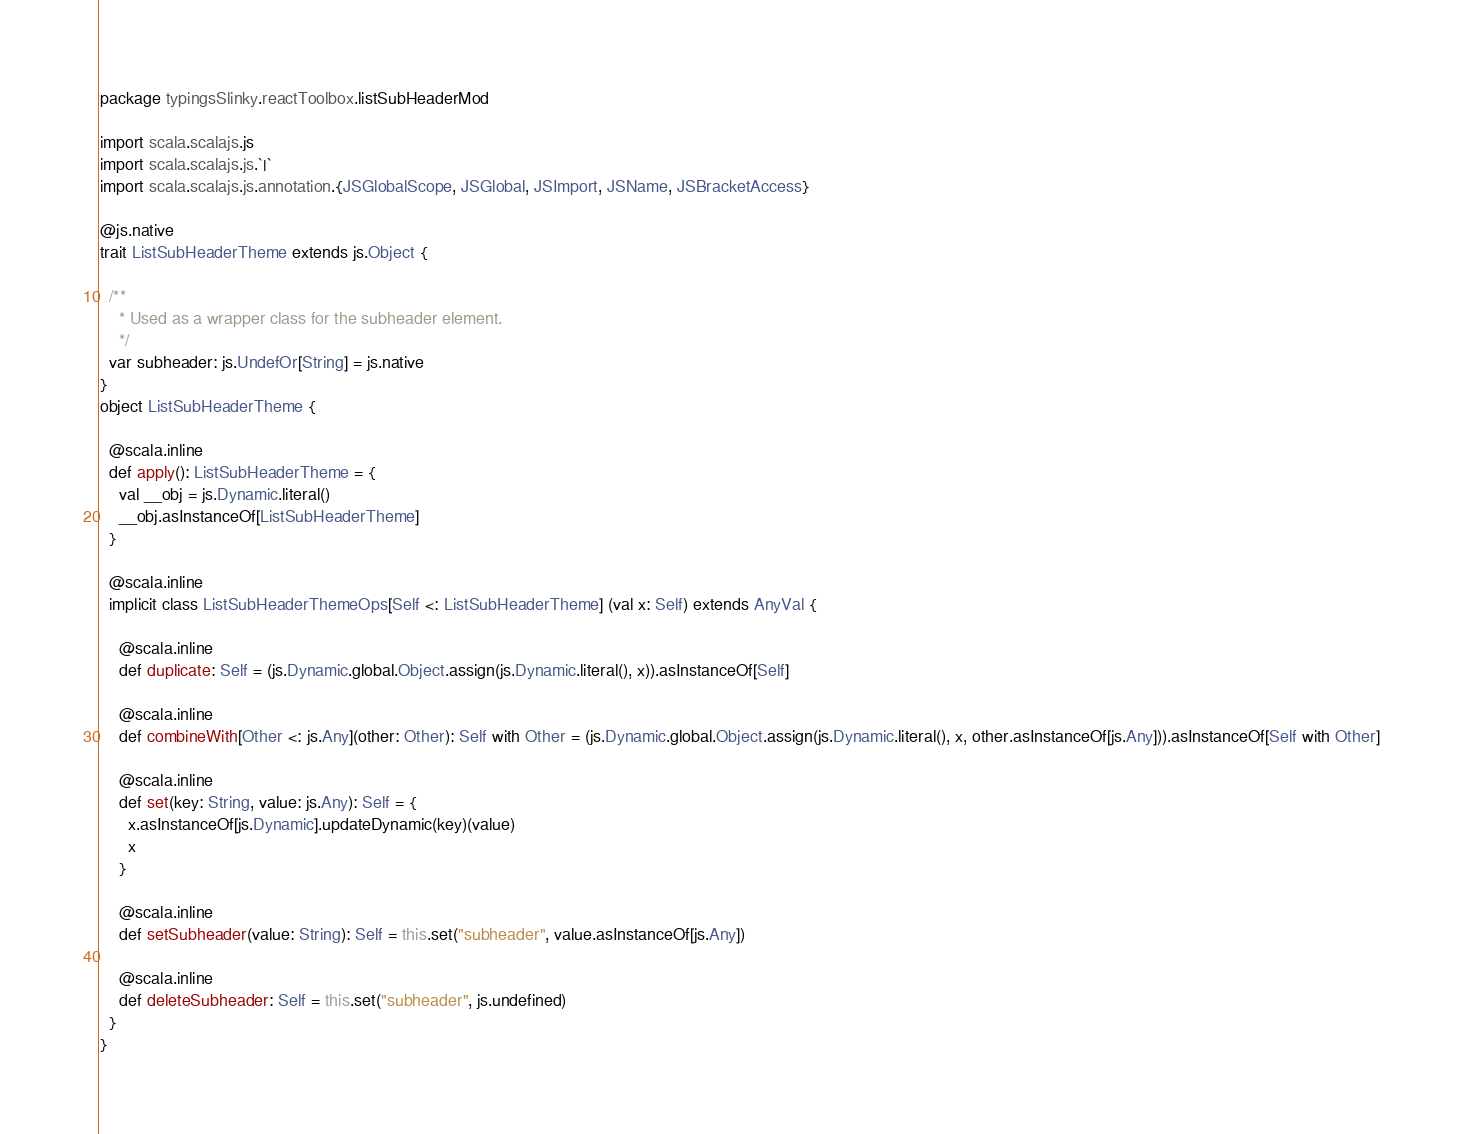Convert code to text. <code><loc_0><loc_0><loc_500><loc_500><_Scala_>package typingsSlinky.reactToolbox.listSubHeaderMod

import scala.scalajs.js
import scala.scalajs.js.`|`
import scala.scalajs.js.annotation.{JSGlobalScope, JSGlobal, JSImport, JSName, JSBracketAccess}

@js.native
trait ListSubHeaderTheme extends js.Object {
  
  /**
    * Used as a wrapper class for the subheader element.
    */
  var subheader: js.UndefOr[String] = js.native
}
object ListSubHeaderTheme {
  
  @scala.inline
  def apply(): ListSubHeaderTheme = {
    val __obj = js.Dynamic.literal()
    __obj.asInstanceOf[ListSubHeaderTheme]
  }
  
  @scala.inline
  implicit class ListSubHeaderThemeOps[Self <: ListSubHeaderTheme] (val x: Self) extends AnyVal {
    
    @scala.inline
    def duplicate: Self = (js.Dynamic.global.Object.assign(js.Dynamic.literal(), x)).asInstanceOf[Self]
    
    @scala.inline
    def combineWith[Other <: js.Any](other: Other): Self with Other = (js.Dynamic.global.Object.assign(js.Dynamic.literal(), x, other.asInstanceOf[js.Any])).asInstanceOf[Self with Other]
    
    @scala.inline
    def set(key: String, value: js.Any): Self = {
      x.asInstanceOf[js.Dynamic].updateDynamic(key)(value)
      x
    }
    
    @scala.inline
    def setSubheader(value: String): Self = this.set("subheader", value.asInstanceOf[js.Any])
    
    @scala.inline
    def deleteSubheader: Self = this.set("subheader", js.undefined)
  }
}
</code> 